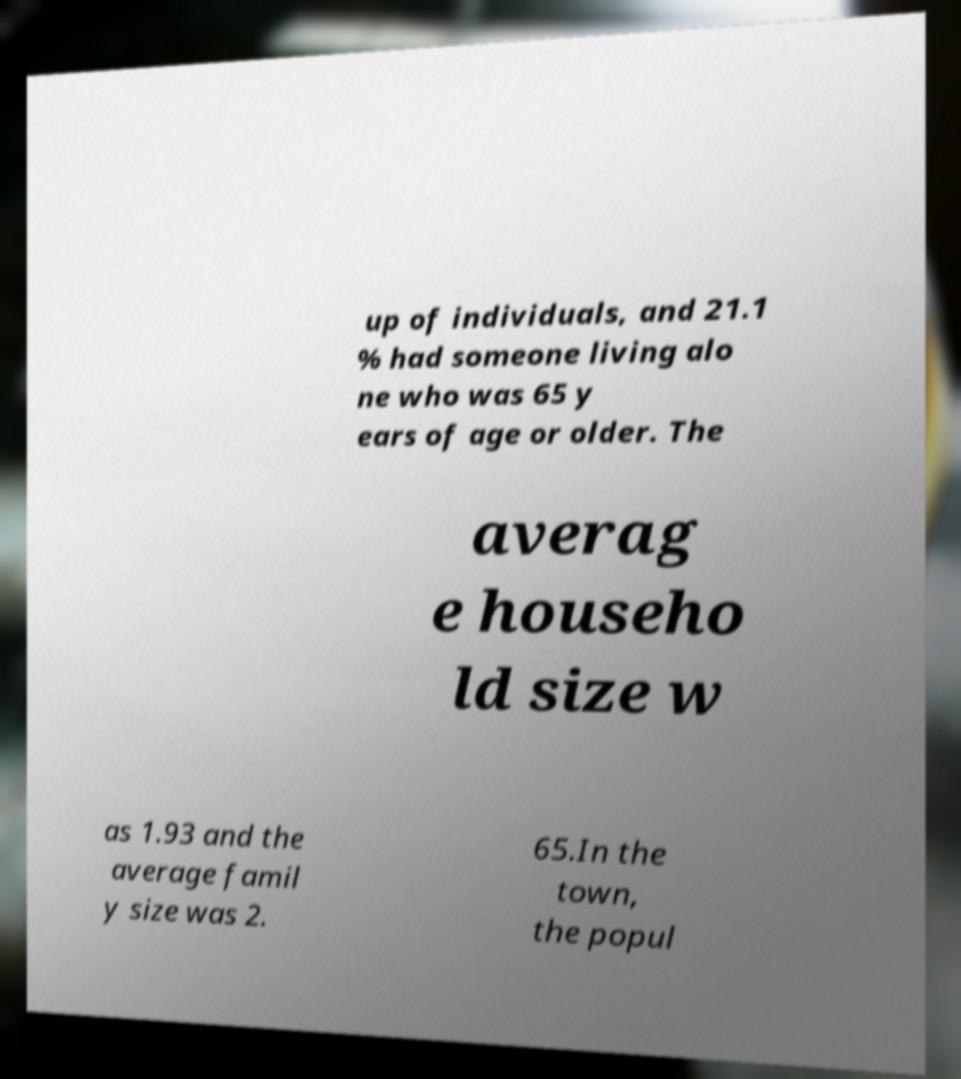I need the written content from this picture converted into text. Can you do that? up of individuals, and 21.1 % had someone living alo ne who was 65 y ears of age or older. The averag e househo ld size w as 1.93 and the average famil y size was 2. 65.In the town, the popul 